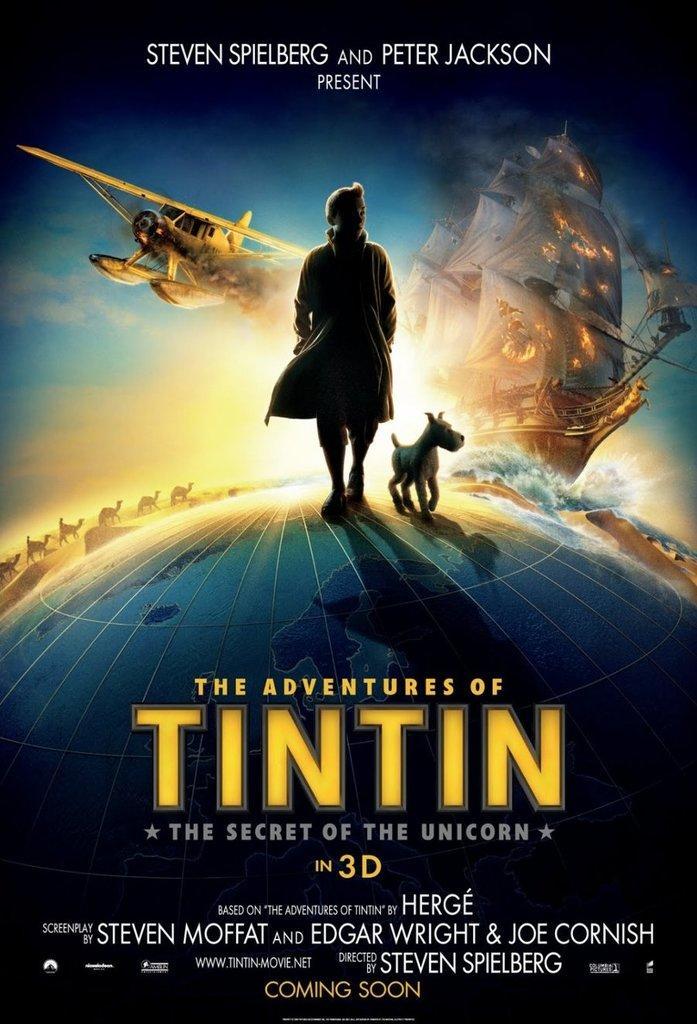In one or two sentences, can you explain what this image depicts? In this image, we can see a poster contains a person, dog, jet and ship. There is text at the bottom of the image. 